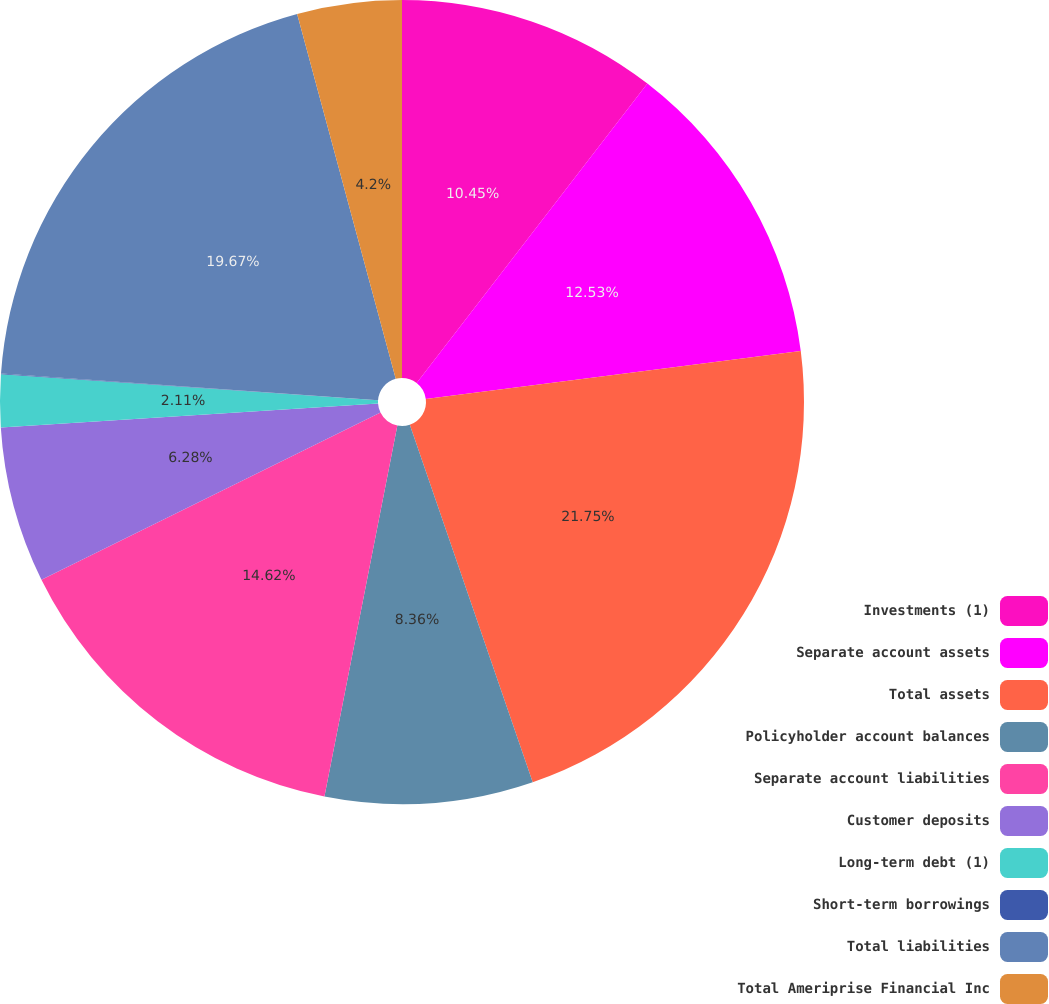Convert chart to OTSL. <chart><loc_0><loc_0><loc_500><loc_500><pie_chart><fcel>Investments (1)<fcel>Separate account assets<fcel>Total assets<fcel>Policyholder account balances<fcel>Separate account liabilities<fcel>Customer deposits<fcel>Long-term debt (1)<fcel>Short-term borrowings<fcel>Total liabilities<fcel>Total Ameriprise Financial Inc<nl><fcel>10.45%<fcel>12.53%<fcel>21.75%<fcel>8.36%<fcel>14.62%<fcel>6.28%<fcel>2.11%<fcel>0.03%<fcel>19.67%<fcel>4.2%<nl></chart> 